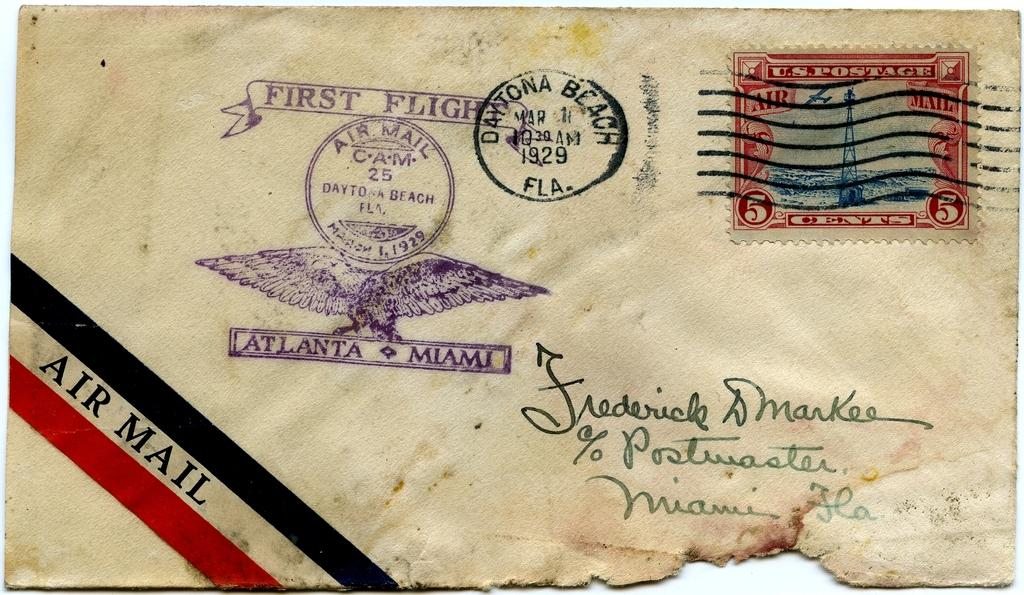<image>
Relay a brief, clear account of the picture shown. An envelope postmarked 1929 from Daytona Beach and sent to Frederick DMarkee. 